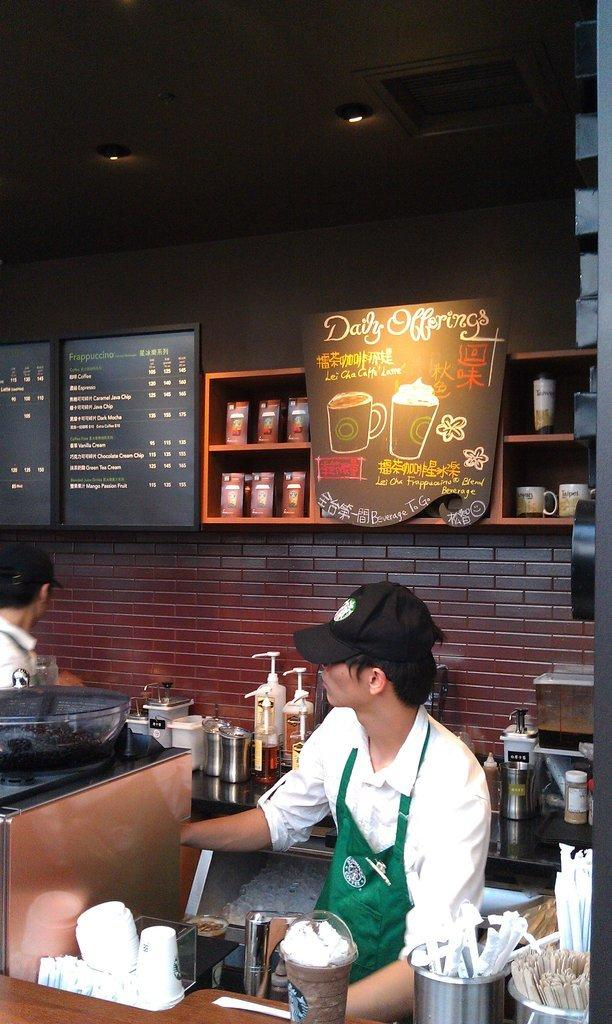<image>
Relay a brief, clear account of the picture shown. a Starbucks barista stands under a sign reading Daily Offerings 